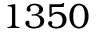Convert formula to latex. <formula><loc_0><loc_0><loc_500><loc_500>1 3 5 0</formula> 